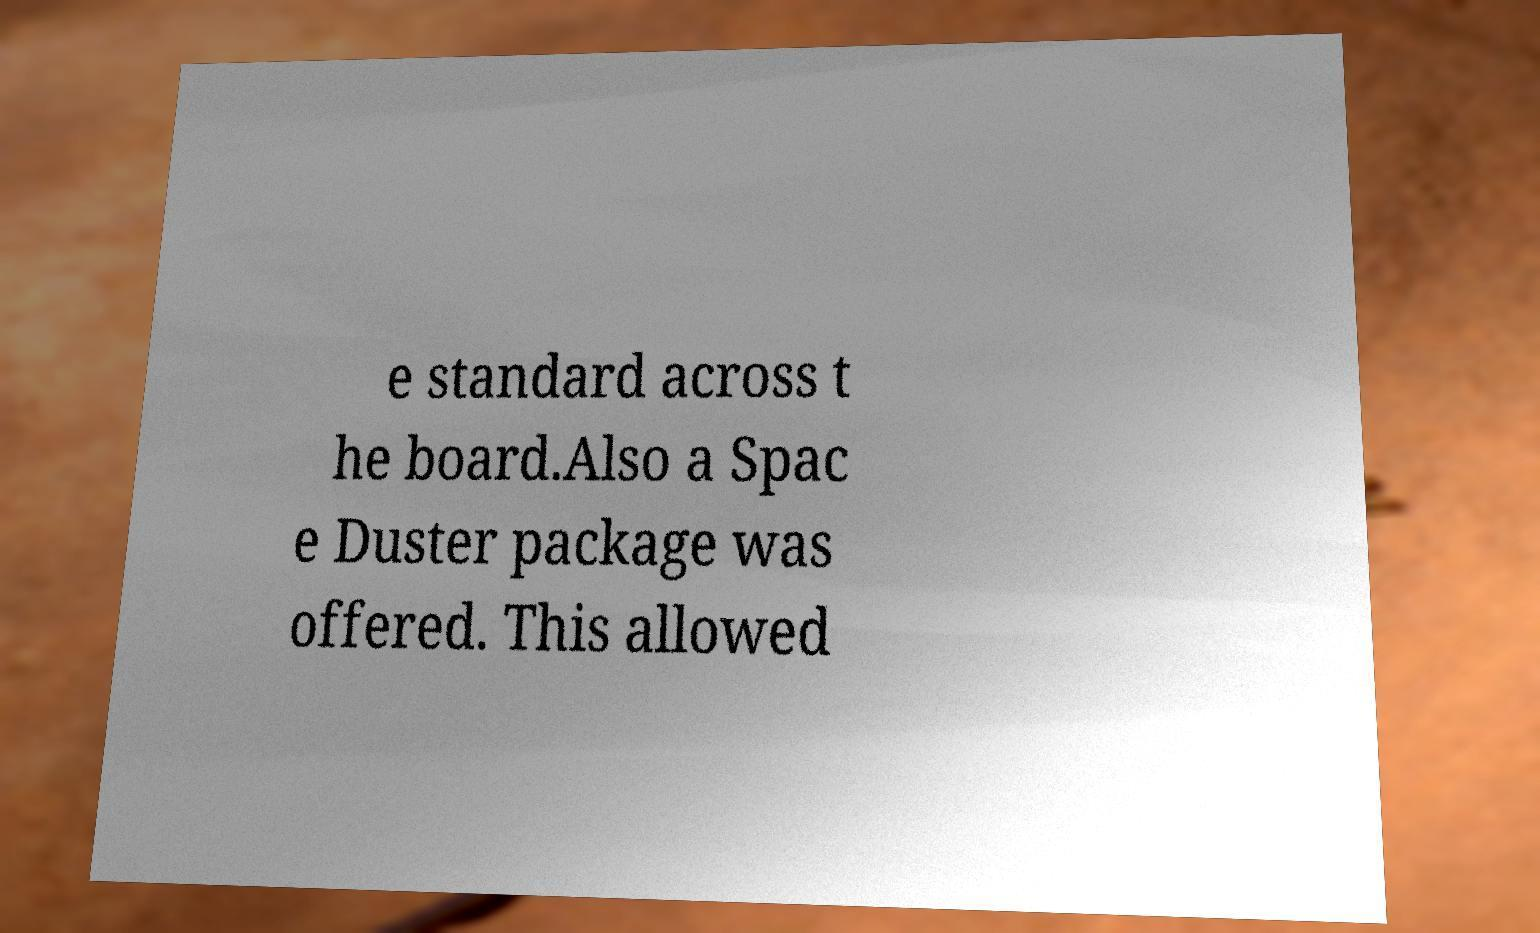Can you read and provide the text displayed in the image?This photo seems to have some interesting text. Can you extract and type it out for me? e standard across t he board.Also a Spac e Duster package was offered. This allowed 